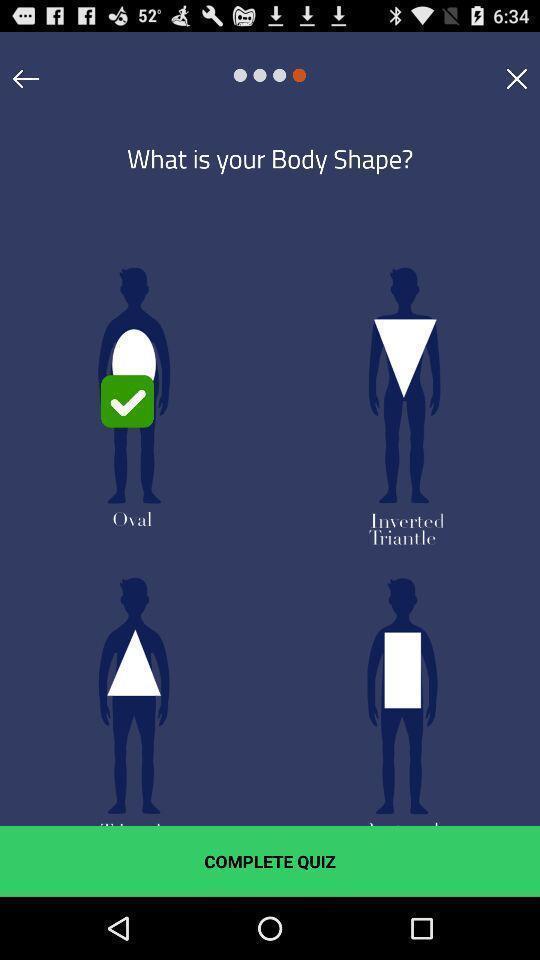Describe the content in this image. Page is about quiz on body shape for shopping app. 